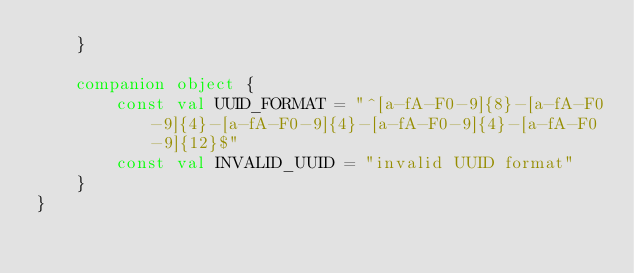Convert code to text. <code><loc_0><loc_0><loc_500><loc_500><_Kotlin_>    }

    companion object {
        const val UUID_FORMAT = "^[a-fA-F0-9]{8}-[a-fA-F0-9]{4}-[a-fA-F0-9]{4}-[a-fA-F0-9]{4}-[a-fA-F0-9]{12}$"
        const val INVALID_UUID = "invalid UUID format"
    }
}
</code> 